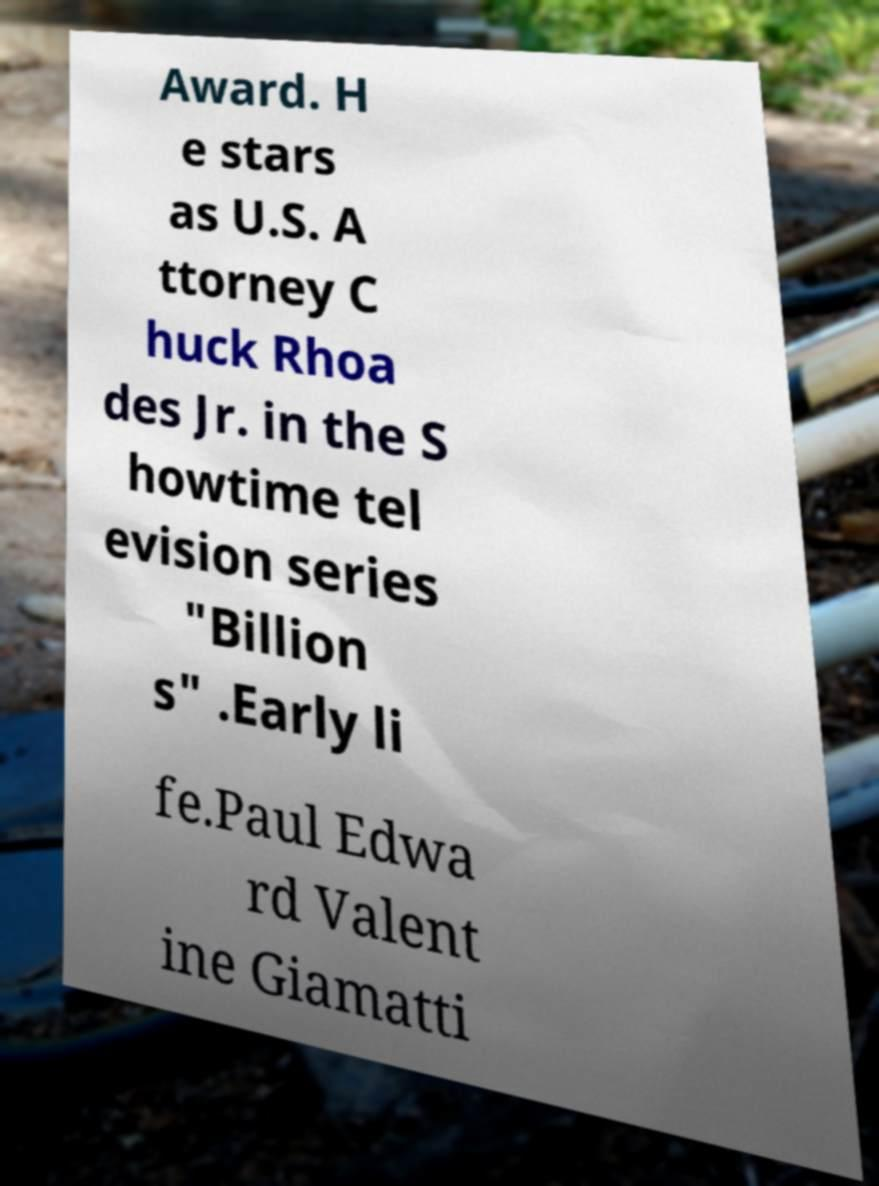Can you read and provide the text displayed in the image?This photo seems to have some interesting text. Can you extract and type it out for me? Award. H e stars as U.S. A ttorney C huck Rhoa des Jr. in the S howtime tel evision series "Billion s" .Early li fe.Paul Edwa rd Valent ine Giamatti 